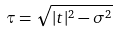<formula> <loc_0><loc_0><loc_500><loc_500>\tau = \sqrt { | t | ^ { 2 } - \sigma ^ { 2 } }</formula> 